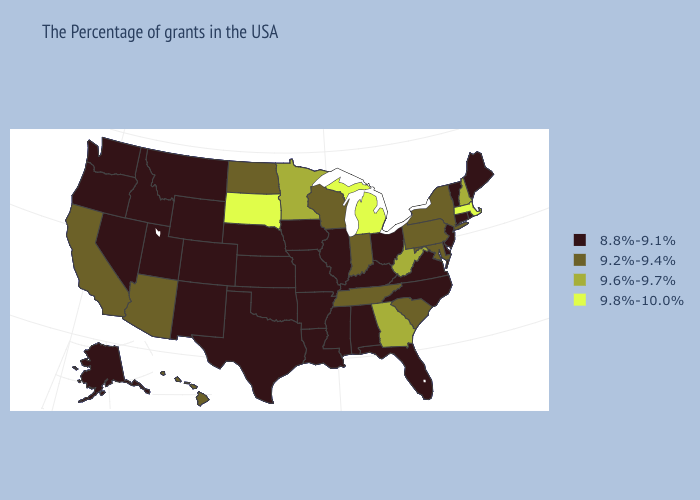What is the value of Hawaii?
Answer briefly. 9.2%-9.4%. Among the states that border Wyoming , which have the highest value?
Short answer required. South Dakota. What is the lowest value in the South?
Keep it brief. 8.8%-9.1%. Does Rhode Island have the lowest value in the Northeast?
Quick response, please. Yes. Name the states that have a value in the range 9.8%-10.0%?
Answer briefly. Massachusetts, Michigan, South Dakota. What is the value of New York?
Give a very brief answer. 9.2%-9.4%. Among the states that border Montana , which have the highest value?
Answer briefly. South Dakota. Among the states that border Ohio , which have the highest value?
Write a very short answer. Michigan. Among the states that border Vermont , does New York have the highest value?
Write a very short answer. No. Is the legend a continuous bar?
Give a very brief answer. No. Name the states that have a value in the range 8.8%-9.1%?
Quick response, please. Maine, Rhode Island, Vermont, Connecticut, New Jersey, Delaware, Virginia, North Carolina, Ohio, Florida, Kentucky, Alabama, Illinois, Mississippi, Louisiana, Missouri, Arkansas, Iowa, Kansas, Nebraska, Oklahoma, Texas, Wyoming, Colorado, New Mexico, Utah, Montana, Idaho, Nevada, Washington, Oregon, Alaska. Which states have the lowest value in the West?
Answer briefly. Wyoming, Colorado, New Mexico, Utah, Montana, Idaho, Nevada, Washington, Oregon, Alaska. Name the states that have a value in the range 8.8%-9.1%?
Give a very brief answer. Maine, Rhode Island, Vermont, Connecticut, New Jersey, Delaware, Virginia, North Carolina, Ohio, Florida, Kentucky, Alabama, Illinois, Mississippi, Louisiana, Missouri, Arkansas, Iowa, Kansas, Nebraska, Oklahoma, Texas, Wyoming, Colorado, New Mexico, Utah, Montana, Idaho, Nevada, Washington, Oregon, Alaska. Name the states that have a value in the range 9.6%-9.7%?
Concise answer only. New Hampshire, West Virginia, Georgia, Minnesota. 